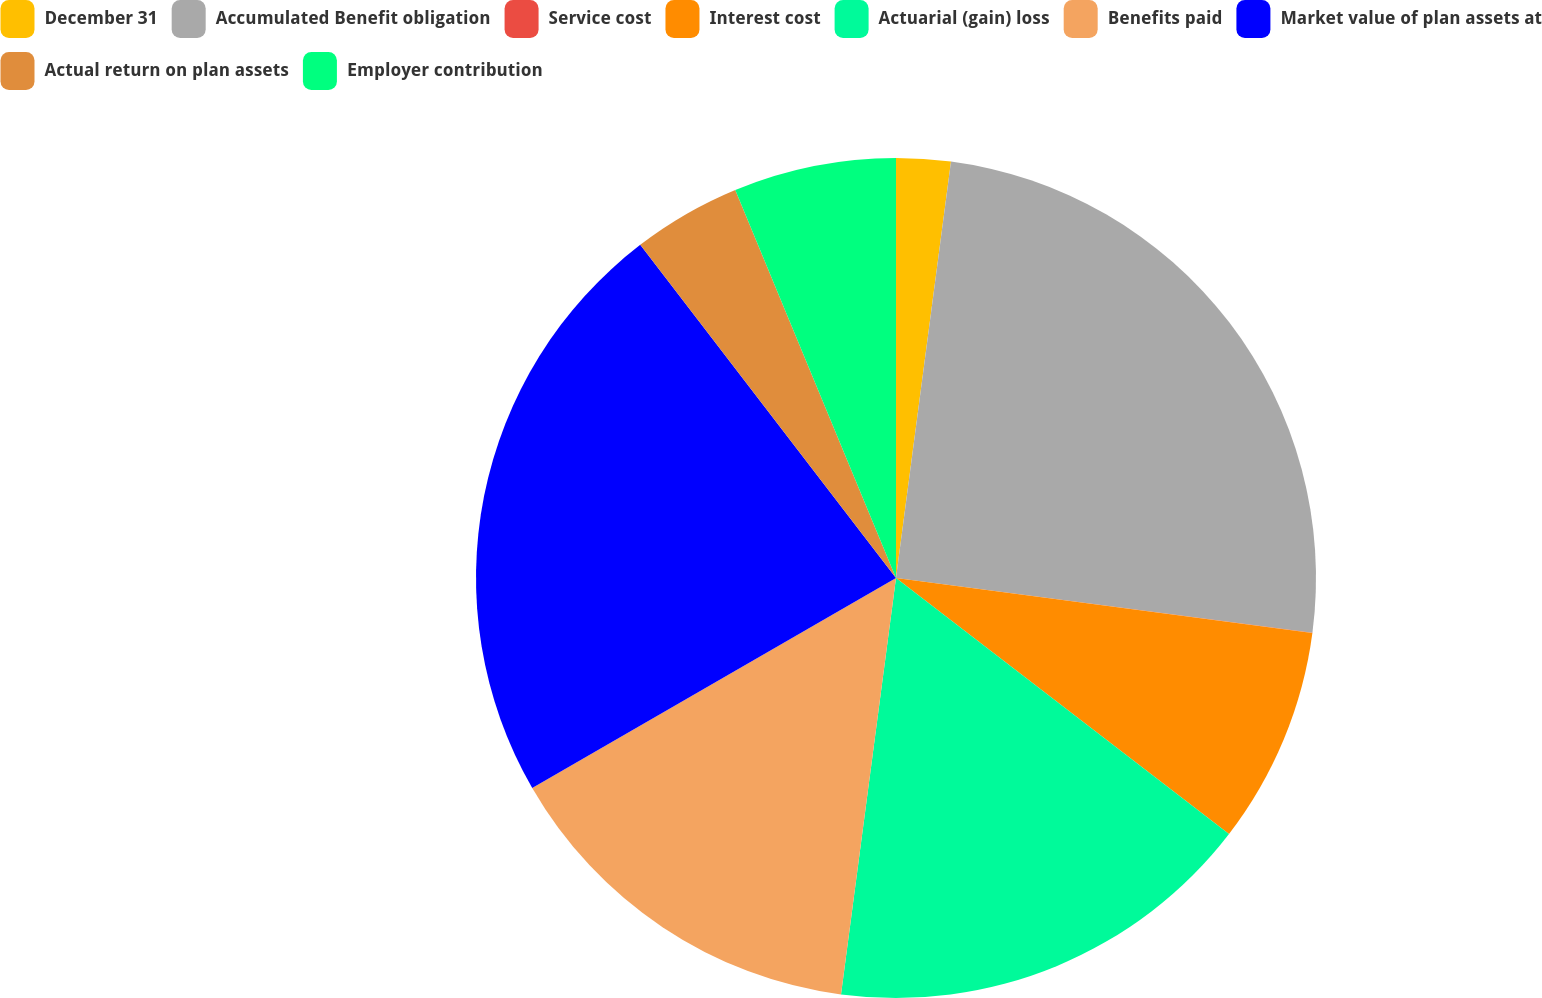<chart> <loc_0><loc_0><loc_500><loc_500><pie_chart><fcel>December 31<fcel>Accumulated Benefit obligation<fcel>Service cost<fcel>Interest cost<fcel>Actuarial (gain) loss<fcel>Benefits paid<fcel>Market value of plan assets at<fcel>Actual return on plan assets<fcel>Employer contribution<nl><fcel>2.09%<fcel>24.99%<fcel>0.01%<fcel>8.34%<fcel>16.66%<fcel>14.58%<fcel>22.91%<fcel>4.17%<fcel>6.25%<nl></chart> 